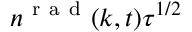<formula> <loc_0><loc_0><loc_500><loc_500>n ^ { r a d } ( k , t ) \tau ^ { 1 / 2 }</formula> 